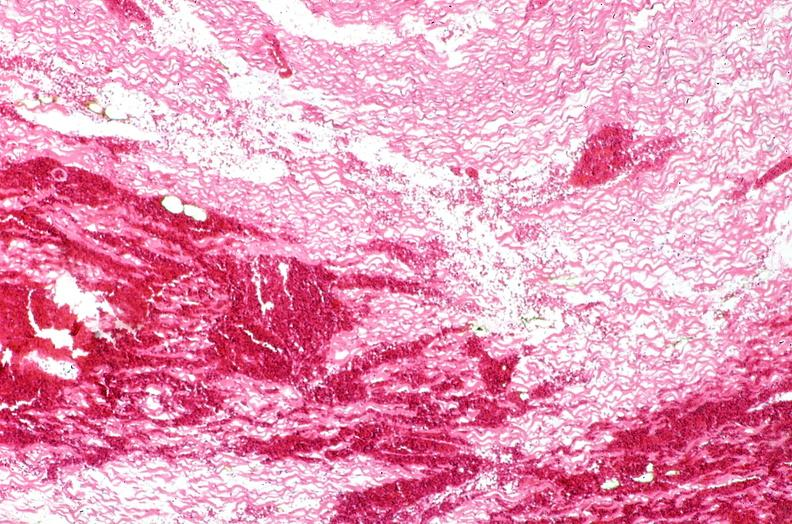s cardiovascular present?
Answer the question using a single word or phrase. Yes 